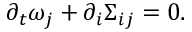<formula> <loc_0><loc_0><loc_500><loc_500>\begin{array} { r } { \partial _ { t } \omega _ { j } + \partial _ { i } \Sigma _ { i j } = 0 . } \end{array}</formula> 